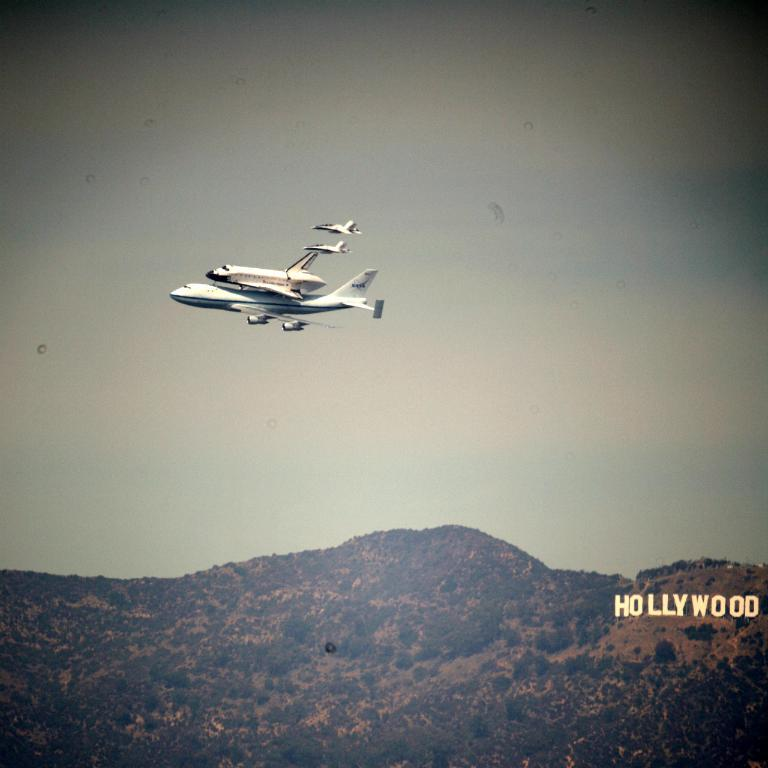<image>
Describe the image concisely. several planes are flying over the Hollywood sign 